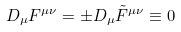<formula> <loc_0><loc_0><loc_500><loc_500>D _ { \mu } F ^ { \mu \nu } = \pm D _ { \mu } \tilde { F } ^ { \mu \nu } \equiv 0</formula> 